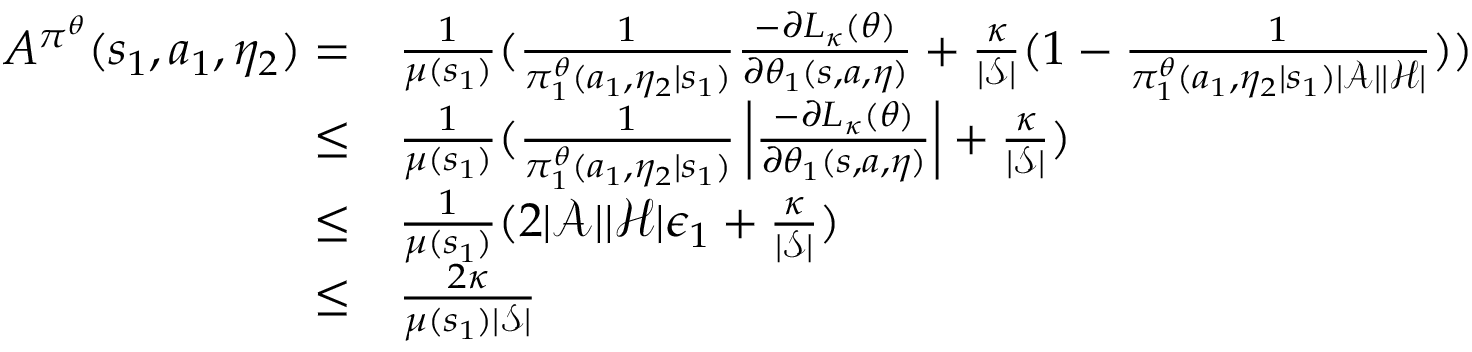<formula> <loc_0><loc_0><loc_500><loc_500>\begin{array} { r l } { A ^ { \pi ^ { \theta } } ( s _ { 1 } , a _ { 1 } , \eta _ { 2 } ) = } & { \frac { 1 } { \mu ( s _ { 1 } ) } ( \frac { 1 } { \pi _ { 1 } ^ { \theta } ( a _ { 1 } , \eta _ { 2 } | s _ { 1 } ) } \frac { - \partial L _ { \kappa } ( \theta ) } { \partial \theta _ { 1 } ( s , a , \eta ) } + \frac { \kappa } { | \mathcal { S } | } ( 1 - \frac { 1 } { \pi _ { 1 } ^ { \theta } ( a _ { 1 } , \eta _ { 2 } | s _ { 1 } ) | \mathcal { A } | | \mathcal { H } | } ) ) } \\ { \leq } & { \frac { 1 } { \mu ( s _ { 1 } ) } ( \frac { 1 } { \pi _ { 1 } ^ { \theta } ( a _ { 1 } , \eta _ { 2 } | s _ { 1 } ) } \left | \frac { - \partial L _ { \kappa } ( \theta ) } { \partial \theta _ { 1 } ( s , a , \eta ) } \right | + \frac { \kappa } { | \mathcal { S } | } ) } \\ { \leq } & { \frac { 1 } { \mu ( s _ { 1 } ) } ( 2 | \mathcal { A } | | \mathcal { H } | \epsilon _ { 1 } + \frac { \kappa } { | \mathcal { S } | } ) } \\ { \leq } & { \frac { 2 \kappa } { \mu ( s _ { 1 } ) | \mathcal { S } | } } \end{array}</formula> 